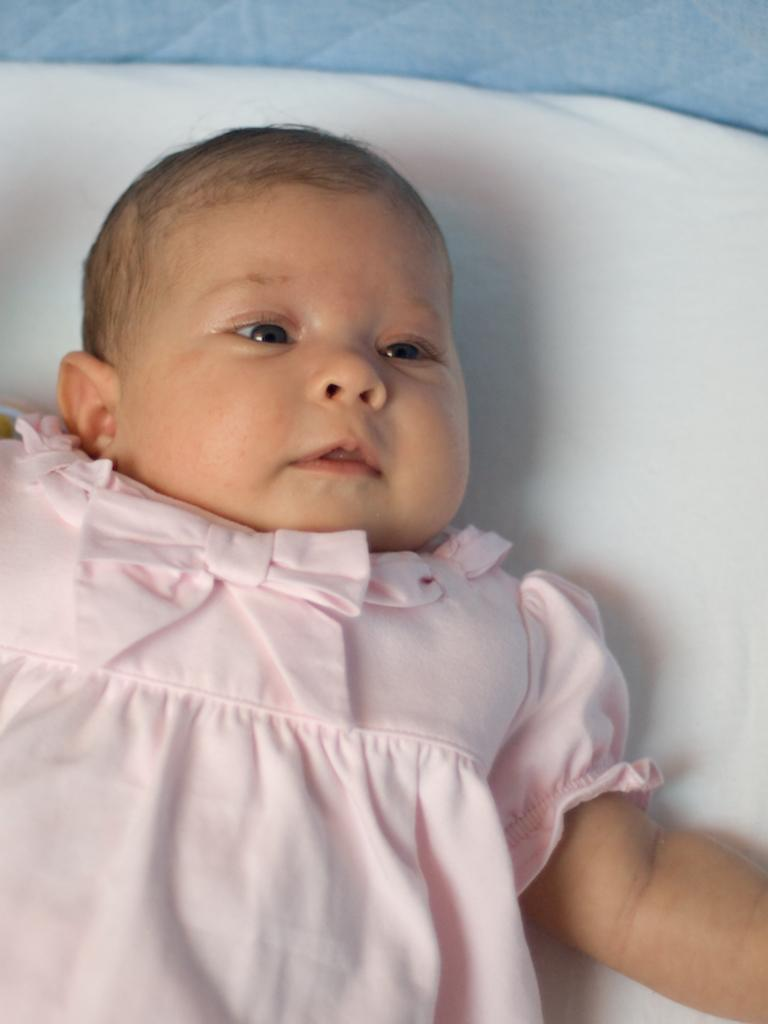What is the main subject of the image? The main subject of the image is a baby. What is the baby wearing in the image? The baby is wearing a light pink dress. What is the baby laying on in the image? The baby is laying on a white color bed. Can you hear any bells ringing in the image? There is no mention of bells or any sound in the image, so it cannot be determined if bells are ringing. Is there a porter present in the image? There is no mention of a porter or any person assisting with luggage in the image. 